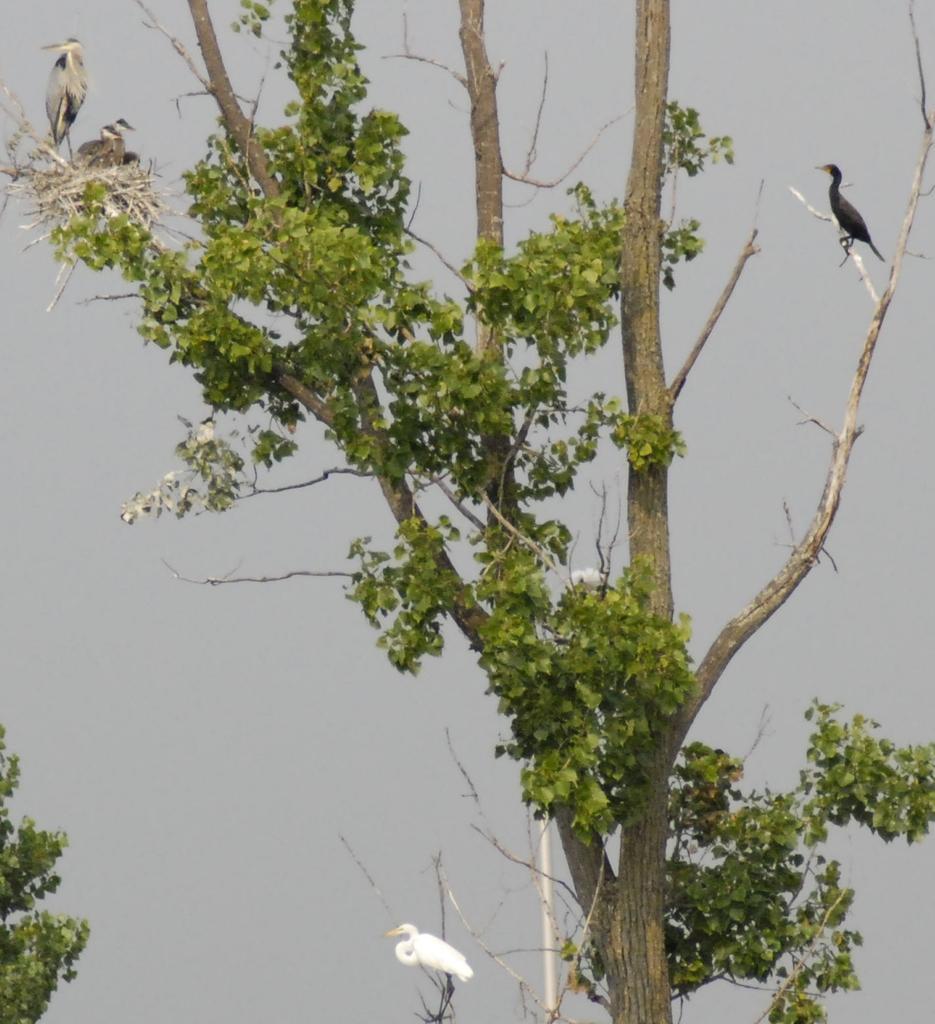Can you describe this image briefly? In the image there is a tree. On the branches of the tree there is a nest and also there are few birds standing. Behind the tree there is a grey color background. 